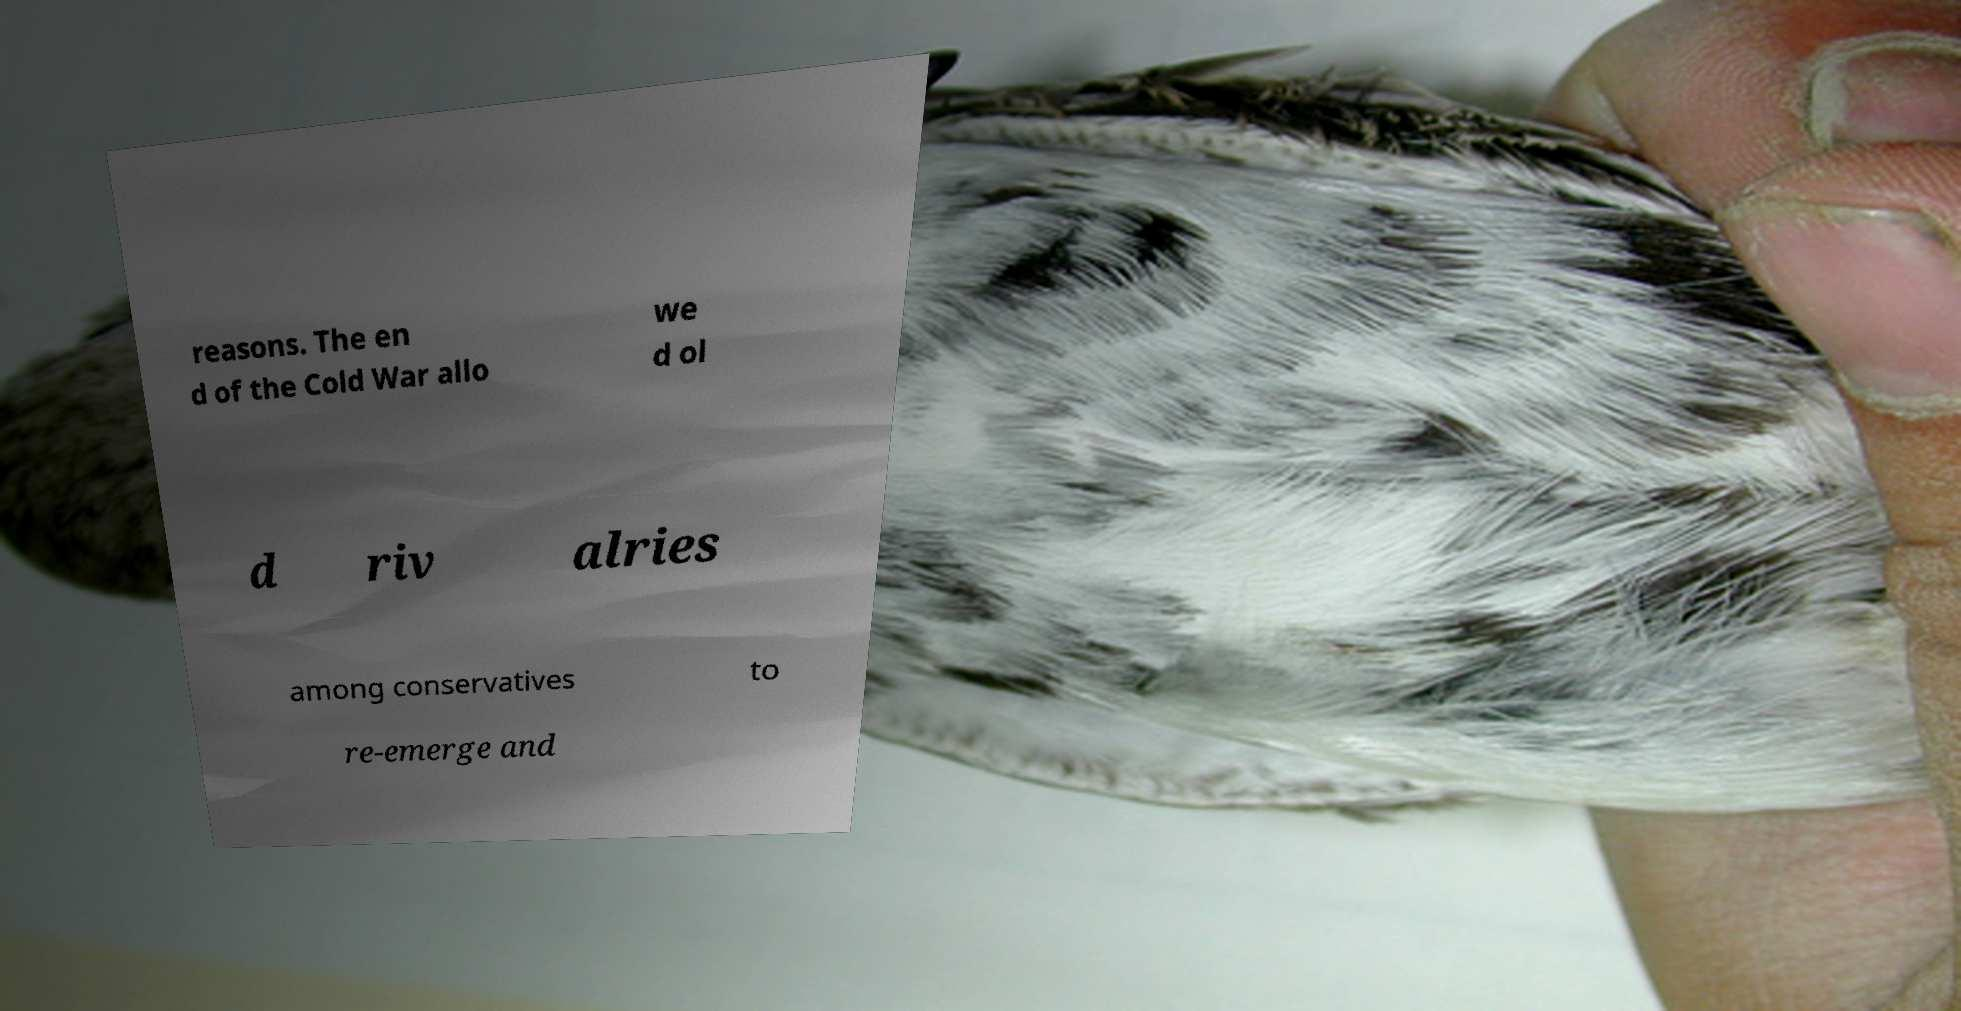Can you read and provide the text displayed in the image?This photo seems to have some interesting text. Can you extract and type it out for me? reasons. The en d of the Cold War allo we d ol d riv alries among conservatives to re-emerge and 